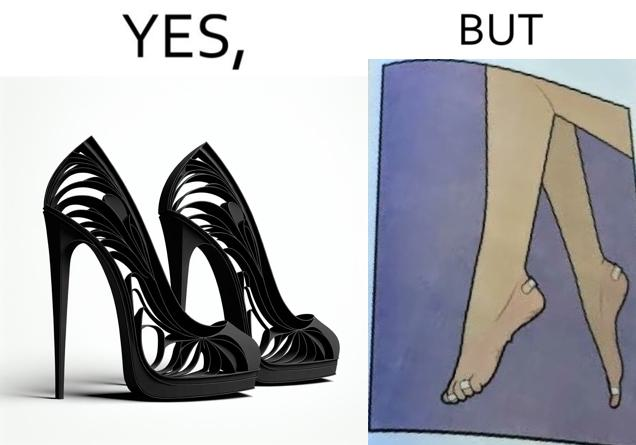Is this image satirical or non-satirical? Yes, this image is satirical. 